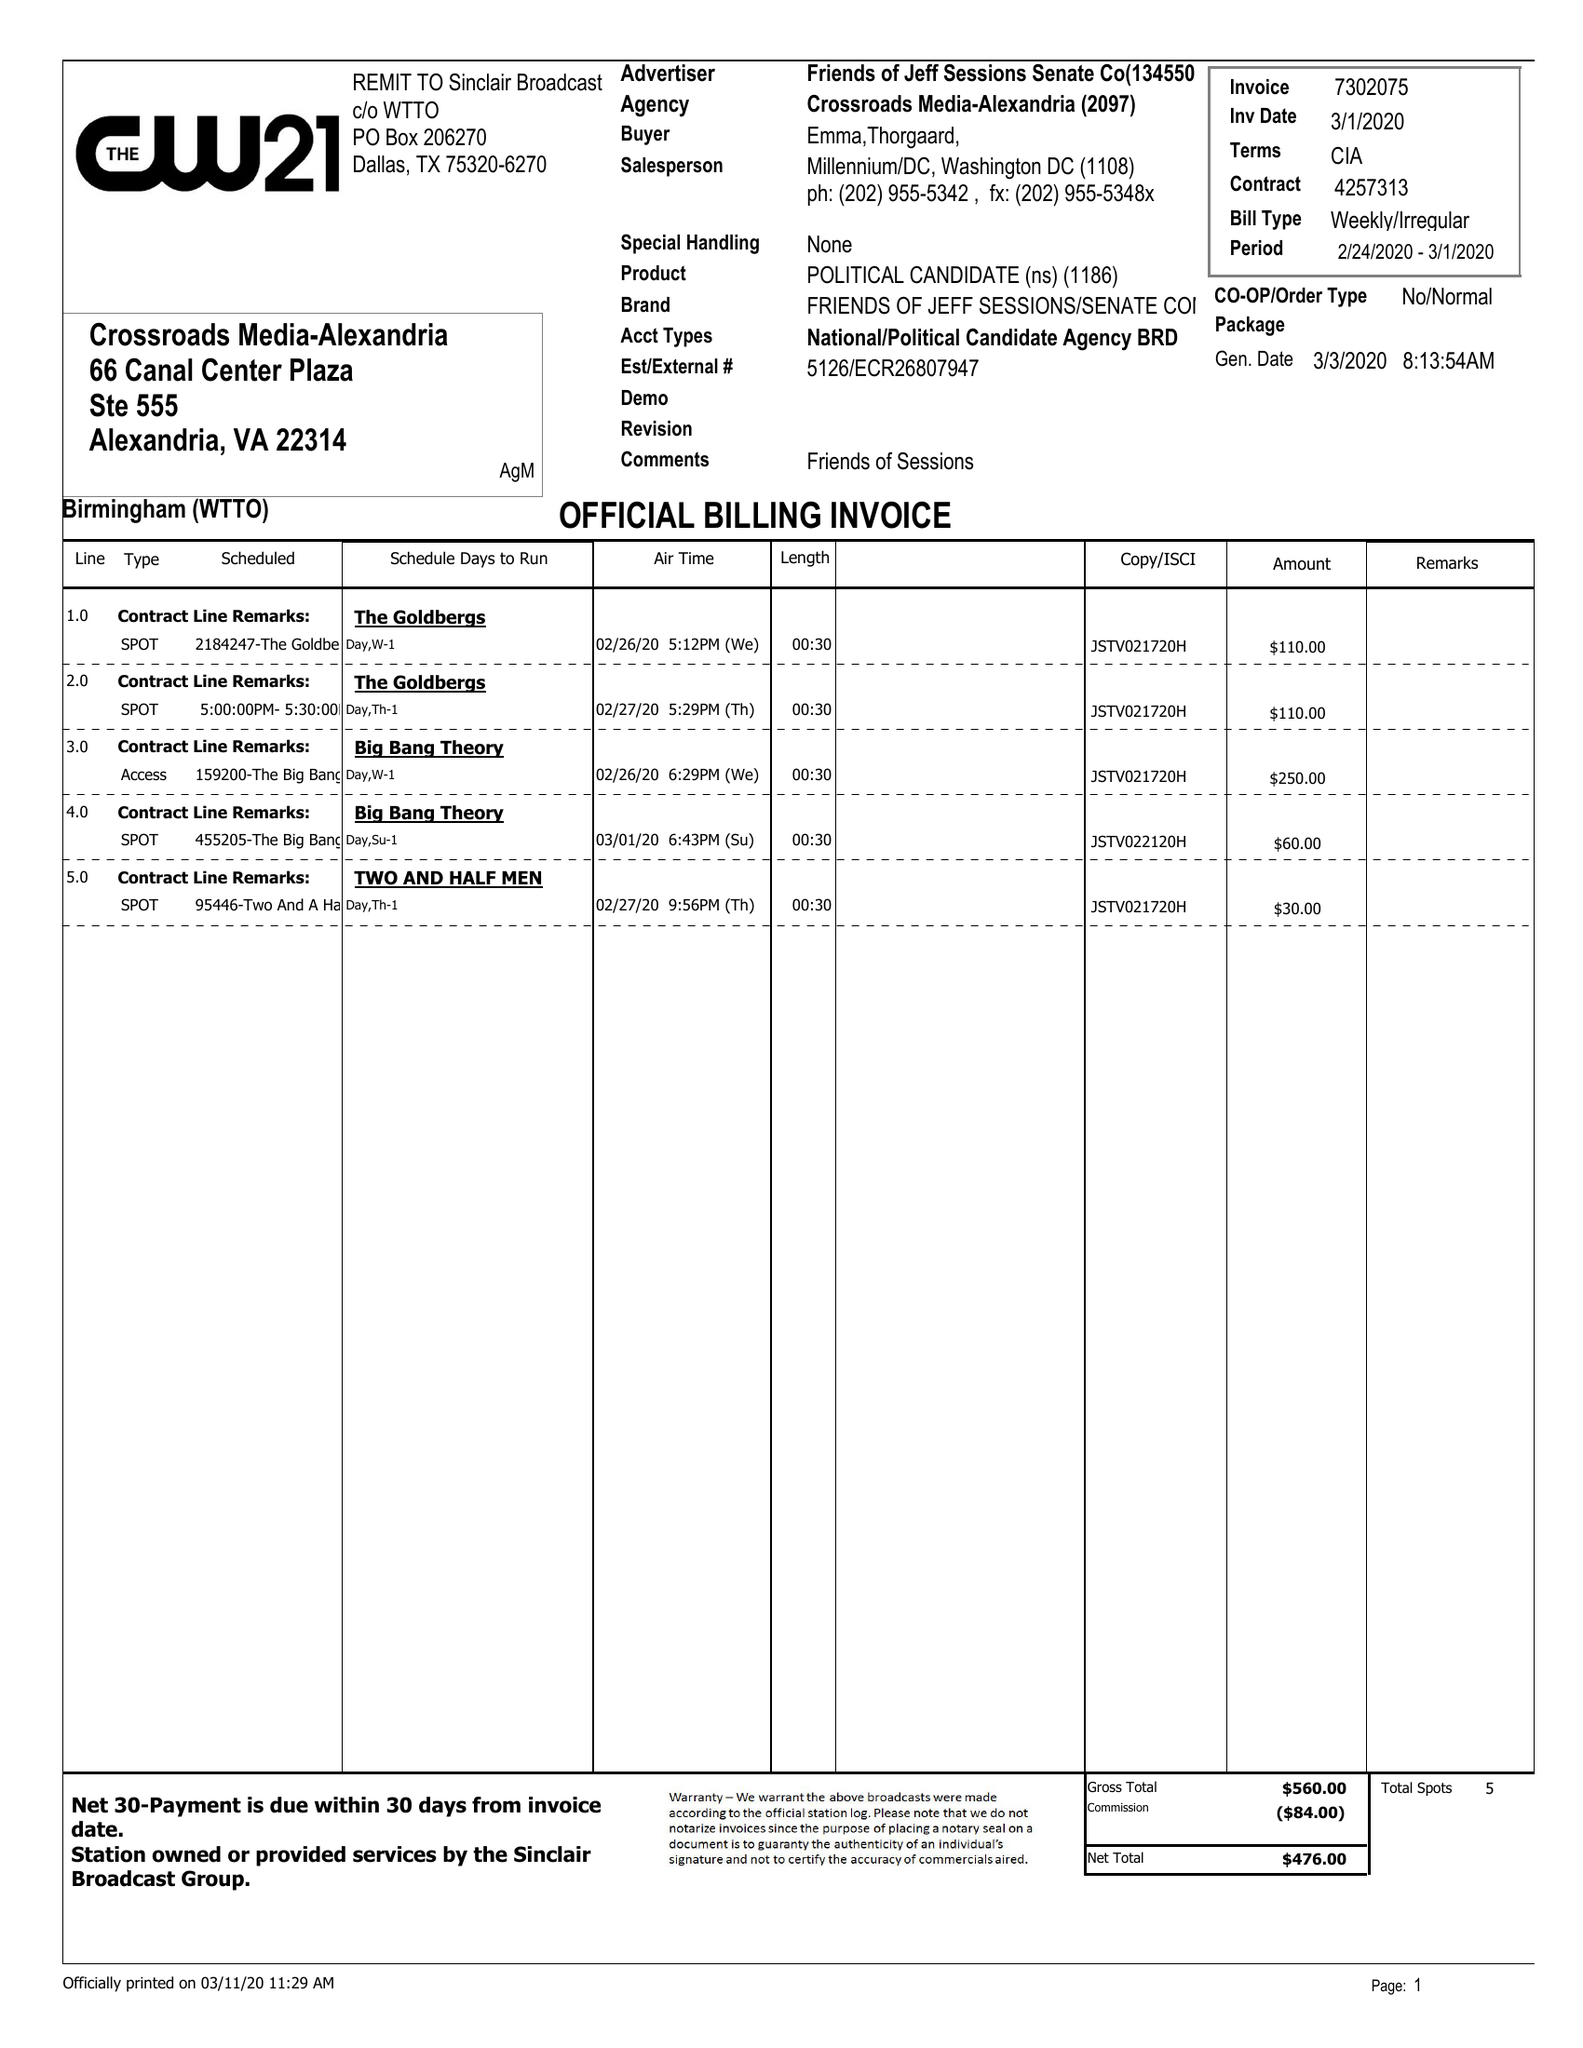What is the value for the flight_to?
Answer the question using a single word or phrase. 03/01/20 